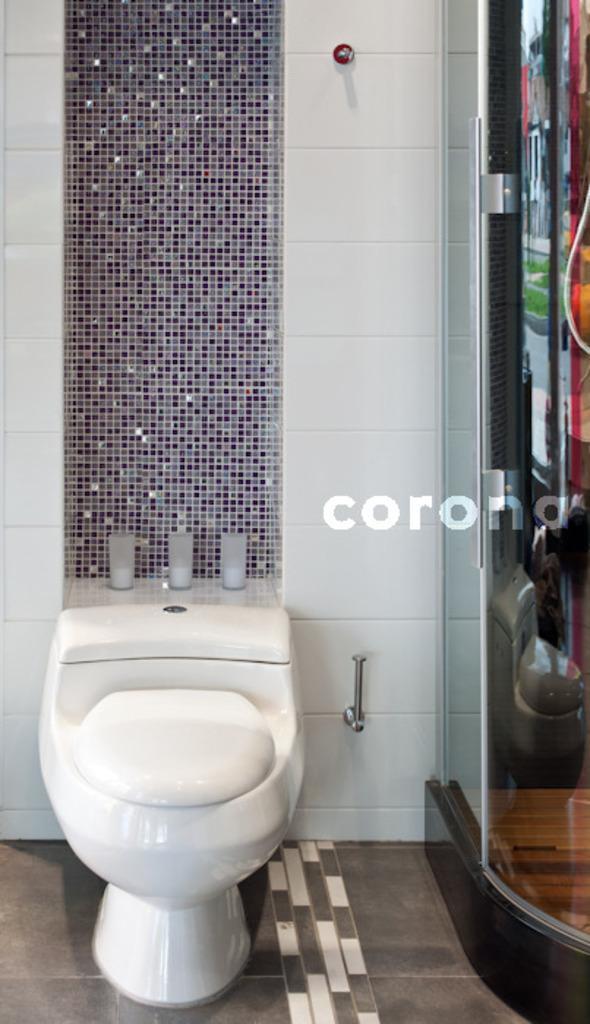Can you describe this image briefly? In this picture we can see a toilet seat, metal rods and a wall, beside to the toilet seat we can find a door. 